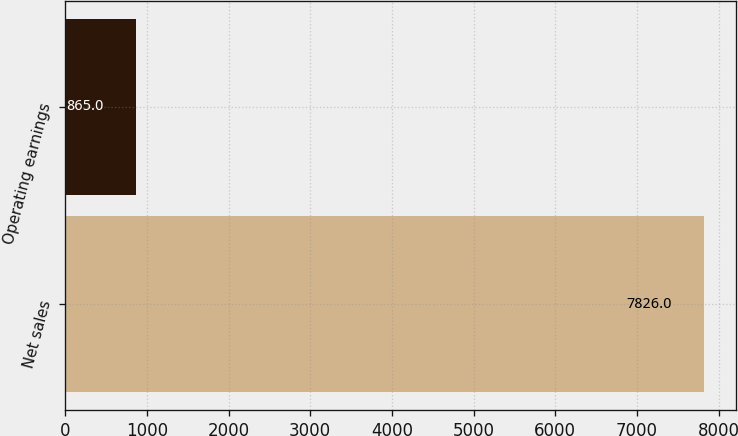<chart> <loc_0><loc_0><loc_500><loc_500><bar_chart><fcel>Net sales<fcel>Operating earnings<nl><fcel>7826<fcel>865<nl></chart> 